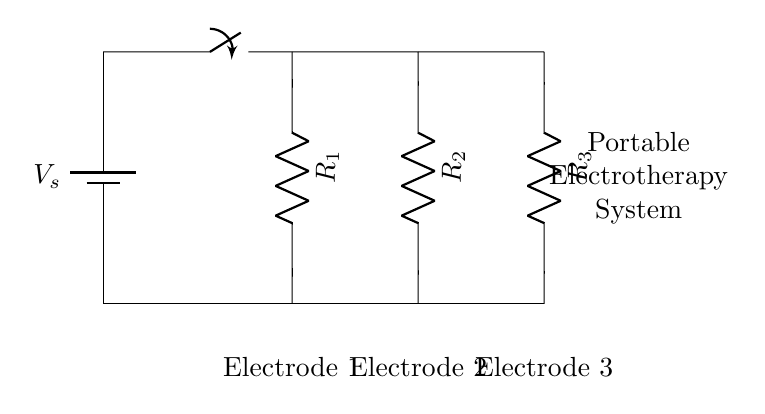What is the total number of resistors in the circuit? There are three resistors in the circuit, labeled R1, R2, and R3, which are all connected in parallel.
Answer: 3 What is the configuration type of this circuit? The circuit is configured in parallel, as indicated by multiple branches (R1, R2, R3) connecting between the same two nodes.
Answer: Parallel What components connect the top part of the circuit? The battery and switch connect the top part of the circuit, where the voltage source is controlled by the switch.
Answer: Battery, switch What is the function of the resistors in this circuit? The resistors (R1, R2, R3) in this circuit control the current through each branch, allowing for independent adjustments of pain management at each electrode.
Answer: Control current How many electrodes are used in this system? The system uses three electrodes, as labeled directly beneath the resistors on the circuit diagram.
Answer: 3 Why is the parallel configuration beneficial for this electrotherapy system? The parallel configuration allows each electrode to operate independently; this means that if one electrode has an issue, the others continue to function, ensuring consistent therapy delivery.
Answer: Independent operation 